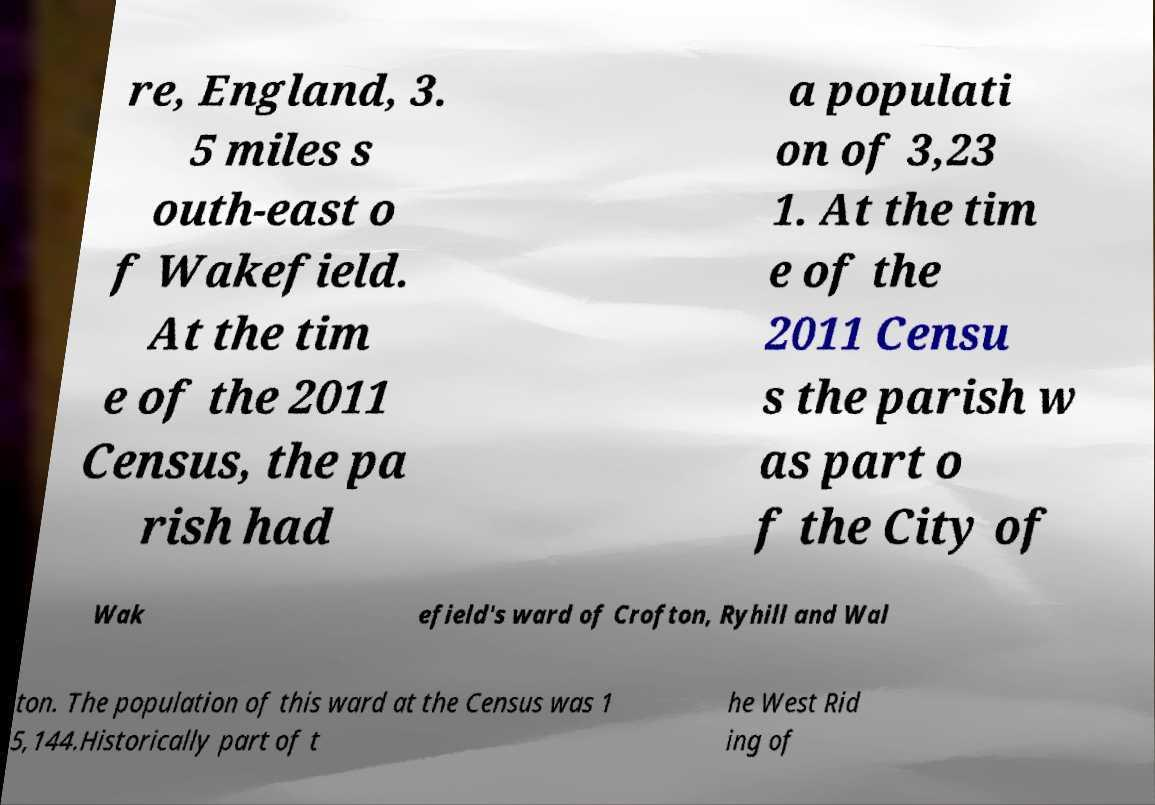There's text embedded in this image that I need extracted. Can you transcribe it verbatim? re, England, 3. 5 miles s outh-east o f Wakefield. At the tim e of the 2011 Census, the pa rish had a populati on of 3,23 1. At the tim e of the 2011 Censu s the parish w as part o f the City of Wak efield's ward of Crofton, Ryhill and Wal ton. The population of this ward at the Census was 1 5,144.Historically part of t he West Rid ing of 